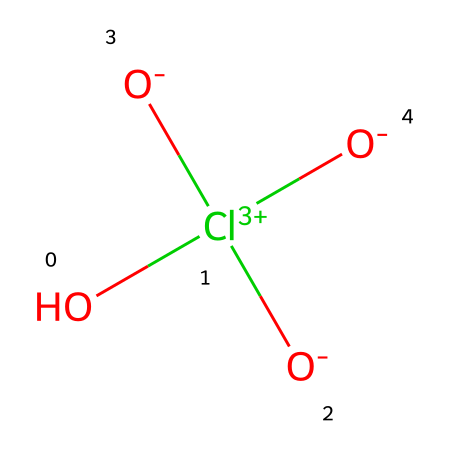What is the molecular formula of perchloric acid? The SMILES notation indicates that it contains one chlorine (Cl) and four oxygen (O) atoms, which correlates to a molecular formula of HClO4.
Answer: HClO4 How many oxygen atoms are present in perchloric acid? By examining the structure represented in the SMILES notation, I can count four oxygen atoms attached to the chlorine atom.
Answer: four What is the oxidation state of chlorine in perchloric acid? Considering the oxidation numbers, chlorine typically has an oxidation state of +7 in perchloric acid since it is bonded to four oxygen atoms, each contributing a -2 charge. Therefore, the calculation is +7 from Cl and -8 from O gives zero overall.
Answer: +7 What type of chemical is perchloric acid classified as? Based on its structure and properties, perchloric acid is classified as a strong oxidizing agent due to the presence of the chlorine atom in a high oxidation state, which facilitates its reactivity with other substances.
Answer: oxidizer How many total covalent bonds are present in perchloric acid? In the structure detailed by SMILES, the central chlorine atom forms four double bonds with the four oxygen atoms, totaling four covalent bonds.
Answer: four Is perchloric acid a strong or weak acid? The structure's presence of strong electron-withdrawing oxygen atoms indicates that perchloric acid is a strong acid, fully dissociating in solution.
Answer: strong What is the primary use of perchloric acid in space propulsion? Perchloric acid's main utility in space propulsion systems lies in its role as a highly efficient oxidizer, capable of rapidly supplying oxygen for combustion in rocket propellants.
Answer: oxidizer 